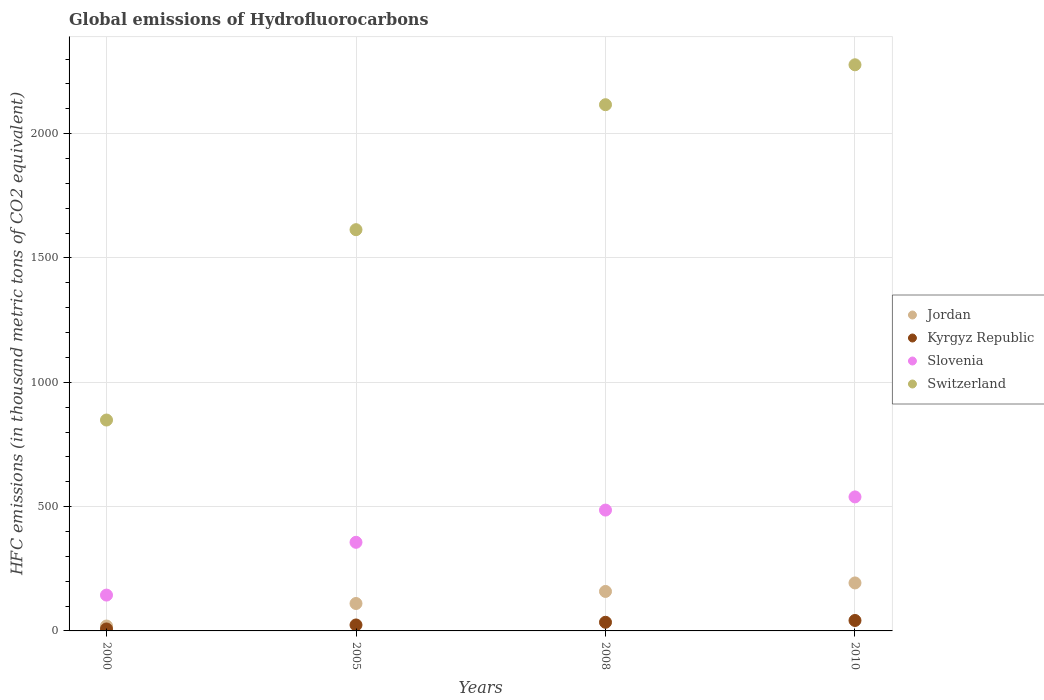How many different coloured dotlines are there?
Provide a short and direct response. 4. What is the global emissions of Hydrofluorocarbons in Switzerland in 2000?
Make the answer very short. 848.2. Across all years, what is the maximum global emissions of Hydrofluorocarbons in Switzerland?
Make the answer very short. 2277. In which year was the global emissions of Hydrofluorocarbons in Switzerland maximum?
Your response must be concise. 2010. What is the total global emissions of Hydrofluorocarbons in Switzerland in the graph?
Offer a very short reply. 6855.4. What is the difference between the global emissions of Hydrofluorocarbons in Switzerland in 2005 and that in 2010?
Give a very brief answer. -663.2. What is the difference between the global emissions of Hydrofluorocarbons in Switzerland in 2005 and the global emissions of Hydrofluorocarbons in Slovenia in 2010?
Provide a succinct answer. 1074.8. What is the average global emissions of Hydrofluorocarbons in Slovenia per year?
Your response must be concise. 381.38. In the year 2000, what is the difference between the global emissions of Hydrofluorocarbons in Jordan and global emissions of Hydrofluorocarbons in Slovenia?
Your answer should be compact. -124.4. What is the ratio of the global emissions of Hydrofluorocarbons in Jordan in 2000 to that in 2010?
Provide a succinct answer. 0.1. Is the global emissions of Hydrofluorocarbons in Kyrgyz Republic in 2005 less than that in 2010?
Keep it short and to the point. Yes. What is the difference between the highest and the second highest global emissions of Hydrofluorocarbons in Kyrgyz Republic?
Your answer should be compact. 7.2. What is the difference between the highest and the lowest global emissions of Hydrofluorocarbons in Jordan?
Provide a succinct answer. 173.3. In how many years, is the global emissions of Hydrofluorocarbons in Slovenia greater than the average global emissions of Hydrofluorocarbons in Slovenia taken over all years?
Your answer should be very brief. 2. Is it the case that in every year, the sum of the global emissions of Hydrofluorocarbons in Switzerland and global emissions of Hydrofluorocarbons in Slovenia  is greater than the sum of global emissions of Hydrofluorocarbons in Kyrgyz Republic and global emissions of Hydrofluorocarbons in Jordan?
Provide a succinct answer. Yes. Is the global emissions of Hydrofluorocarbons in Jordan strictly greater than the global emissions of Hydrofluorocarbons in Kyrgyz Republic over the years?
Your response must be concise. Yes. Is the global emissions of Hydrofluorocarbons in Switzerland strictly less than the global emissions of Hydrofluorocarbons in Jordan over the years?
Your answer should be very brief. No. How many dotlines are there?
Make the answer very short. 4. How many years are there in the graph?
Your response must be concise. 4. What is the difference between two consecutive major ticks on the Y-axis?
Offer a very short reply. 500. Does the graph contain any zero values?
Keep it short and to the point. No. Does the graph contain grids?
Offer a very short reply. Yes. How many legend labels are there?
Make the answer very short. 4. What is the title of the graph?
Make the answer very short. Global emissions of Hydrofluorocarbons. Does "Montenegro" appear as one of the legend labels in the graph?
Your answer should be very brief. No. What is the label or title of the Y-axis?
Offer a very short reply. HFC emissions (in thousand metric tons of CO2 equivalent). What is the HFC emissions (in thousand metric tons of CO2 equivalent) of Jordan in 2000?
Ensure brevity in your answer.  19.7. What is the HFC emissions (in thousand metric tons of CO2 equivalent) in Kyrgyz Republic in 2000?
Your response must be concise. 7.9. What is the HFC emissions (in thousand metric tons of CO2 equivalent) in Slovenia in 2000?
Give a very brief answer. 144.1. What is the HFC emissions (in thousand metric tons of CO2 equivalent) of Switzerland in 2000?
Give a very brief answer. 848.2. What is the HFC emissions (in thousand metric tons of CO2 equivalent) in Jordan in 2005?
Provide a short and direct response. 110.3. What is the HFC emissions (in thousand metric tons of CO2 equivalent) of Kyrgyz Republic in 2005?
Your response must be concise. 24. What is the HFC emissions (in thousand metric tons of CO2 equivalent) in Slovenia in 2005?
Provide a succinct answer. 356.4. What is the HFC emissions (in thousand metric tons of CO2 equivalent) in Switzerland in 2005?
Provide a short and direct response. 1613.8. What is the HFC emissions (in thousand metric tons of CO2 equivalent) in Jordan in 2008?
Provide a short and direct response. 158.8. What is the HFC emissions (in thousand metric tons of CO2 equivalent) in Kyrgyz Republic in 2008?
Offer a terse response. 34.8. What is the HFC emissions (in thousand metric tons of CO2 equivalent) of Slovenia in 2008?
Your response must be concise. 486. What is the HFC emissions (in thousand metric tons of CO2 equivalent) in Switzerland in 2008?
Your answer should be very brief. 2116.4. What is the HFC emissions (in thousand metric tons of CO2 equivalent) of Jordan in 2010?
Give a very brief answer. 193. What is the HFC emissions (in thousand metric tons of CO2 equivalent) in Slovenia in 2010?
Your response must be concise. 539. What is the HFC emissions (in thousand metric tons of CO2 equivalent) of Switzerland in 2010?
Your response must be concise. 2277. Across all years, what is the maximum HFC emissions (in thousand metric tons of CO2 equivalent) in Jordan?
Ensure brevity in your answer.  193. Across all years, what is the maximum HFC emissions (in thousand metric tons of CO2 equivalent) in Kyrgyz Republic?
Make the answer very short. 42. Across all years, what is the maximum HFC emissions (in thousand metric tons of CO2 equivalent) in Slovenia?
Keep it short and to the point. 539. Across all years, what is the maximum HFC emissions (in thousand metric tons of CO2 equivalent) of Switzerland?
Your answer should be compact. 2277. Across all years, what is the minimum HFC emissions (in thousand metric tons of CO2 equivalent) of Slovenia?
Provide a short and direct response. 144.1. Across all years, what is the minimum HFC emissions (in thousand metric tons of CO2 equivalent) in Switzerland?
Your answer should be very brief. 848.2. What is the total HFC emissions (in thousand metric tons of CO2 equivalent) of Jordan in the graph?
Your answer should be very brief. 481.8. What is the total HFC emissions (in thousand metric tons of CO2 equivalent) in Kyrgyz Republic in the graph?
Your answer should be compact. 108.7. What is the total HFC emissions (in thousand metric tons of CO2 equivalent) in Slovenia in the graph?
Ensure brevity in your answer.  1525.5. What is the total HFC emissions (in thousand metric tons of CO2 equivalent) in Switzerland in the graph?
Give a very brief answer. 6855.4. What is the difference between the HFC emissions (in thousand metric tons of CO2 equivalent) in Jordan in 2000 and that in 2005?
Keep it short and to the point. -90.6. What is the difference between the HFC emissions (in thousand metric tons of CO2 equivalent) of Kyrgyz Republic in 2000 and that in 2005?
Make the answer very short. -16.1. What is the difference between the HFC emissions (in thousand metric tons of CO2 equivalent) in Slovenia in 2000 and that in 2005?
Give a very brief answer. -212.3. What is the difference between the HFC emissions (in thousand metric tons of CO2 equivalent) of Switzerland in 2000 and that in 2005?
Keep it short and to the point. -765.6. What is the difference between the HFC emissions (in thousand metric tons of CO2 equivalent) in Jordan in 2000 and that in 2008?
Make the answer very short. -139.1. What is the difference between the HFC emissions (in thousand metric tons of CO2 equivalent) of Kyrgyz Republic in 2000 and that in 2008?
Your answer should be very brief. -26.9. What is the difference between the HFC emissions (in thousand metric tons of CO2 equivalent) in Slovenia in 2000 and that in 2008?
Keep it short and to the point. -341.9. What is the difference between the HFC emissions (in thousand metric tons of CO2 equivalent) of Switzerland in 2000 and that in 2008?
Give a very brief answer. -1268.2. What is the difference between the HFC emissions (in thousand metric tons of CO2 equivalent) in Jordan in 2000 and that in 2010?
Keep it short and to the point. -173.3. What is the difference between the HFC emissions (in thousand metric tons of CO2 equivalent) of Kyrgyz Republic in 2000 and that in 2010?
Your answer should be very brief. -34.1. What is the difference between the HFC emissions (in thousand metric tons of CO2 equivalent) in Slovenia in 2000 and that in 2010?
Keep it short and to the point. -394.9. What is the difference between the HFC emissions (in thousand metric tons of CO2 equivalent) in Switzerland in 2000 and that in 2010?
Offer a very short reply. -1428.8. What is the difference between the HFC emissions (in thousand metric tons of CO2 equivalent) of Jordan in 2005 and that in 2008?
Your answer should be compact. -48.5. What is the difference between the HFC emissions (in thousand metric tons of CO2 equivalent) of Slovenia in 2005 and that in 2008?
Make the answer very short. -129.6. What is the difference between the HFC emissions (in thousand metric tons of CO2 equivalent) in Switzerland in 2005 and that in 2008?
Give a very brief answer. -502.6. What is the difference between the HFC emissions (in thousand metric tons of CO2 equivalent) of Jordan in 2005 and that in 2010?
Provide a short and direct response. -82.7. What is the difference between the HFC emissions (in thousand metric tons of CO2 equivalent) in Kyrgyz Republic in 2005 and that in 2010?
Provide a short and direct response. -18. What is the difference between the HFC emissions (in thousand metric tons of CO2 equivalent) in Slovenia in 2005 and that in 2010?
Make the answer very short. -182.6. What is the difference between the HFC emissions (in thousand metric tons of CO2 equivalent) in Switzerland in 2005 and that in 2010?
Provide a succinct answer. -663.2. What is the difference between the HFC emissions (in thousand metric tons of CO2 equivalent) of Jordan in 2008 and that in 2010?
Provide a succinct answer. -34.2. What is the difference between the HFC emissions (in thousand metric tons of CO2 equivalent) of Slovenia in 2008 and that in 2010?
Provide a succinct answer. -53. What is the difference between the HFC emissions (in thousand metric tons of CO2 equivalent) of Switzerland in 2008 and that in 2010?
Offer a terse response. -160.6. What is the difference between the HFC emissions (in thousand metric tons of CO2 equivalent) of Jordan in 2000 and the HFC emissions (in thousand metric tons of CO2 equivalent) of Kyrgyz Republic in 2005?
Keep it short and to the point. -4.3. What is the difference between the HFC emissions (in thousand metric tons of CO2 equivalent) in Jordan in 2000 and the HFC emissions (in thousand metric tons of CO2 equivalent) in Slovenia in 2005?
Provide a succinct answer. -336.7. What is the difference between the HFC emissions (in thousand metric tons of CO2 equivalent) of Jordan in 2000 and the HFC emissions (in thousand metric tons of CO2 equivalent) of Switzerland in 2005?
Make the answer very short. -1594.1. What is the difference between the HFC emissions (in thousand metric tons of CO2 equivalent) in Kyrgyz Republic in 2000 and the HFC emissions (in thousand metric tons of CO2 equivalent) in Slovenia in 2005?
Give a very brief answer. -348.5. What is the difference between the HFC emissions (in thousand metric tons of CO2 equivalent) of Kyrgyz Republic in 2000 and the HFC emissions (in thousand metric tons of CO2 equivalent) of Switzerland in 2005?
Your answer should be very brief. -1605.9. What is the difference between the HFC emissions (in thousand metric tons of CO2 equivalent) in Slovenia in 2000 and the HFC emissions (in thousand metric tons of CO2 equivalent) in Switzerland in 2005?
Provide a short and direct response. -1469.7. What is the difference between the HFC emissions (in thousand metric tons of CO2 equivalent) in Jordan in 2000 and the HFC emissions (in thousand metric tons of CO2 equivalent) in Kyrgyz Republic in 2008?
Your answer should be very brief. -15.1. What is the difference between the HFC emissions (in thousand metric tons of CO2 equivalent) in Jordan in 2000 and the HFC emissions (in thousand metric tons of CO2 equivalent) in Slovenia in 2008?
Ensure brevity in your answer.  -466.3. What is the difference between the HFC emissions (in thousand metric tons of CO2 equivalent) of Jordan in 2000 and the HFC emissions (in thousand metric tons of CO2 equivalent) of Switzerland in 2008?
Make the answer very short. -2096.7. What is the difference between the HFC emissions (in thousand metric tons of CO2 equivalent) in Kyrgyz Republic in 2000 and the HFC emissions (in thousand metric tons of CO2 equivalent) in Slovenia in 2008?
Make the answer very short. -478.1. What is the difference between the HFC emissions (in thousand metric tons of CO2 equivalent) of Kyrgyz Republic in 2000 and the HFC emissions (in thousand metric tons of CO2 equivalent) of Switzerland in 2008?
Keep it short and to the point. -2108.5. What is the difference between the HFC emissions (in thousand metric tons of CO2 equivalent) of Slovenia in 2000 and the HFC emissions (in thousand metric tons of CO2 equivalent) of Switzerland in 2008?
Provide a succinct answer. -1972.3. What is the difference between the HFC emissions (in thousand metric tons of CO2 equivalent) of Jordan in 2000 and the HFC emissions (in thousand metric tons of CO2 equivalent) of Kyrgyz Republic in 2010?
Your answer should be compact. -22.3. What is the difference between the HFC emissions (in thousand metric tons of CO2 equivalent) in Jordan in 2000 and the HFC emissions (in thousand metric tons of CO2 equivalent) in Slovenia in 2010?
Keep it short and to the point. -519.3. What is the difference between the HFC emissions (in thousand metric tons of CO2 equivalent) of Jordan in 2000 and the HFC emissions (in thousand metric tons of CO2 equivalent) of Switzerland in 2010?
Keep it short and to the point. -2257.3. What is the difference between the HFC emissions (in thousand metric tons of CO2 equivalent) of Kyrgyz Republic in 2000 and the HFC emissions (in thousand metric tons of CO2 equivalent) of Slovenia in 2010?
Keep it short and to the point. -531.1. What is the difference between the HFC emissions (in thousand metric tons of CO2 equivalent) of Kyrgyz Republic in 2000 and the HFC emissions (in thousand metric tons of CO2 equivalent) of Switzerland in 2010?
Provide a short and direct response. -2269.1. What is the difference between the HFC emissions (in thousand metric tons of CO2 equivalent) of Slovenia in 2000 and the HFC emissions (in thousand metric tons of CO2 equivalent) of Switzerland in 2010?
Make the answer very short. -2132.9. What is the difference between the HFC emissions (in thousand metric tons of CO2 equivalent) of Jordan in 2005 and the HFC emissions (in thousand metric tons of CO2 equivalent) of Kyrgyz Republic in 2008?
Provide a succinct answer. 75.5. What is the difference between the HFC emissions (in thousand metric tons of CO2 equivalent) of Jordan in 2005 and the HFC emissions (in thousand metric tons of CO2 equivalent) of Slovenia in 2008?
Offer a very short reply. -375.7. What is the difference between the HFC emissions (in thousand metric tons of CO2 equivalent) in Jordan in 2005 and the HFC emissions (in thousand metric tons of CO2 equivalent) in Switzerland in 2008?
Your response must be concise. -2006.1. What is the difference between the HFC emissions (in thousand metric tons of CO2 equivalent) in Kyrgyz Republic in 2005 and the HFC emissions (in thousand metric tons of CO2 equivalent) in Slovenia in 2008?
Give a very brief answer. -462. What is the difference between the HFC emissions (in thousand metric tons of CO2 equivalent) of Kyrgyz Republic in 2005 and the HFC emissions (in thousand metric tons of CO2 equivalent) of Switzerland in 2008?
Make the answer very short. -2092.4. What is the difference between the HFC emissions (in thousand metric tons of CO2 equivalent) in Slovenia in 2005 and the HFC emissions (in thousand metric tons of CO2 equivalent) in Switzerland in 2008?
Offer a very short reply. -1760. What is the difference between the HFC emissions (in thousand metric tons of CO2 equivalent) of Jordan in 2005 and the HFC emissions (in thousand metric tons of CO2 equivalent) of Kyrgyz Republic in 2010?
Your answer should be very brief. 68.3. What is the difference between the HFC emissions (in thousand metric tons of CO2 equivalent) in Jordan in 2005 and the HFC emissions (in thousand metric tons of CO2 equivalent) in Slovenia in 2010?
Give a very brief answer. -428.7. What is the difference between the HFC emissions (in thousand metric tons of CO2 equivalent) of Jordan in 2005 and the HFC emissions (in thousand metric tons of CO2 equivalent) of Switzerland in 2010?
Provide a succinct answer. -2166.7. What is the difference between the HFC emissions (in thousand metric tons of CO2 equivalent) of Kyrgyz Republic in 2005 and the HFC emissions (in thousand metric tons of CO2 equivalent) of Slovenia in 2010?
Your response must be concise. -515. What is the difference between the HFC emissions (in thousand metric tons of CO2 equivalent) of Kyrgyz Republic in 2005 and the HFC emissions (in thousand metric tons of CO2 equivalent) of Switzerland in 2010?
Your response must be concise. -2253. What is the difference between the HFC emissions (in thousand metric tons of CO2 equivalent) in Slovenia in 2005 and the HFC emissions (in thousand metric tons of CO2 equivalent) in Switzerland in 2010?
Provide a short and direct response. -1920.6. What is the difference between the HFC emissions (in thousand metric tons of CO2 equivalent) in Jordan in 2008 and the HFC emissions (in thousand metric tons of CO2 equivalent) in Kyrgyz Republic in 2010?
Offer a very short reply. 116.8. What is the difference between the HFC emissions (in thousand metric tons of CO2 equivalent) in Jordan in 2008 and the HFC emissions (in thousand metric tons of CO2 equivalent) in Slovenia in 2010?
Make the answer very short. -380.2. What is the difference between the HFC emissions (in thousand metric tons of CO2 equivalent) of Jordan in 2008 and the HFC emissions (in thousand metric tons of CO2 equivalent) of Switzerland in 2010?
Your answer should be very brief. -2118.2. What is the difference between the HFC emissions (in thousand metric tons of CO2 equivalent) in Kyrgyz Republic in 2008 and the HFC emissions (in thousand metric tons of CO2 equivalent) in Slovenia in 2010?
Provide a short and direct response. -504.2. What is the difference between the HFC emissions (in thousand metric tons of CO2 equivalent) in Kyrgyz Republic in 2008 and the HFC emissions (in thousand metric tons of CO2 equivalent) in Switzerland in 2010?
Your answer should be very brief. -2242.2. What is the difference between the HFC emissions (in thousand metric tons of CO2 equivalent) in Slovenia in 2008 and the HFC emissions (in thousand metric tons of CO2 equivalent) in Switzerland in 2010?
Your answer should be compact. -1791. What is the average HFC emissions (in thousand metric tons of CO2 equivalent) of Jordan per year?
Give a very brief answer. 120.45. What is the average HFC emissions (in thousand metric tons of CO2 equivalent) in Kyrgyz Republic per year?
Give a very brief answer. 27.18. What is the average HFC emissions (in thousand metric tons of CO2 equivalent) in Slovenia per year?
Your response must be concise. 381.38. What is the average HFC emissions (in thousand metric tons of CO2 equivalent) in Switzerland per year?
Your answer should be compact. 1713.85. In the year 2000, what is the difference between the HFC emissions (in thousand metric tons of CO2 equivalent) in Jordan and HFC emissions (in thousand metric tons of CO2 equivalent) in Slovenia?
Offer a very short reply. -124.4. In the year 2000, what is the difference between the HFC emissions (in thousand metric tons of CO2 equivalent) of Jordan and HFC emissions (in thousand metric tons of CO2 equivalent) of Switzerland?
Offer a very short reply. -828.5. In the year 2000, what is the difference between the HFC emissions (in thousand metric tons of CO2 equivalent) in Kyrgyz Republic and HFC emissions (in thousand metric tons of CO2 equivalent) in Slovenia?
Provide a short and direct response. -136.2. In the year 2000, what is the difference between the HFC emissions (in thousand metric tons of CO2 equivalent) of Kyrgyz Republic and HFC emissions (in thousand metric tons of CO2 equivalent) of Switzerland?
Provide a short and direct response. -840.3. In the year 2000, what is the difference between the HFC emissions (in thousand metric tons of CO2 equivalent) in Slovenia and HFC emissions (in thousand metric tons of CO2 equivalent) in Switzerland?
Ensure brevity in your answer.  -704.1. In the year 2005, what is the difference between the HFC emissions (in thousand metric tons of CO2 equivalent) in Jordan and HFC emissions (in thousand metric tons of CO2 equivalent) in Kyrgyz Republic?
Provide a succinct answer. 86.3. In the year 2005, what is the difference between the HFC emissions (in thousand metric tons of CO2 equivalent) in Jordan and HFC emissions (in thousand metric tons of CO2 equivalent) in Slovenia?
Provide a succinct answer. -246.1. In the year 2005, what is the difference between the HFC emissions (in thousand metric tons of CO2 equivalent) of Jordan and HFC emissions (in thousand metric tons of CO2 equivalent) of Switzerland?
Ensure brevity in your answer.  -1503.5. In the year 2005, what is the difference between the HFC emissions (in thousand metric tons of CO2 equivalent) in Kyrgyz Republic and HFC emissions (in thousand metric tons of CO2 equivalent) in Slovenia?
Your answer should be compact. -332.4. In the year 2005, what is the difference between the HFC emissions (in thousand metric tons of CO2 equivalent) of Kyrgyz Republic and HFC emissions (in thousand metric tons of CO2 equivalent) of Switzerland?
Keep it short and to the point. -1589.8. In the year 2005, what is the difference between the HFC emissions (in thousand metric tons of CO2 equivalent) of Slovenia and HFC emissions (in thousand metric tons of CO2 equivalent) of Switzerland?
Your response must be concise. -1257.4. In the year 2008, what is the difference between the HFC emissions (in thousand metric tons of CO2 equivalent) of Jordan and HFC emissions (in thousand metric tons of CO2 equivalent) of Kyrgyz Republic?
Your response must be concise. 124. In the year 2008, what is the difference between the HFC emissions (in thousand metric tons of CO2 equivalent) in Jordan and HFC emissions (in thousand metric tons of CO2 equivalent) in Slovenia?
Keep it short and to the point. -327.2. In the year 2008, what is the difference between the HFC emissions (in thousand metric tons of CO2 equivalent) in Jordan and HFC emissions (in thousand metric tons of CO2 equivalent) in Switzerland?
Your response must be concise. -1957.6. In the year 2008, what is the difference between the HFC emissions (in thousand metric tons of CO2 equivalent) of Kyrgyz Republic and HFC emissions (in thousand metric tons of CO2 equivalent) of Slovenia?
Give a very brief answer. -451.2. In the year 2008, what is the difference between the HFC emissions (in thousand metric tons of CO2 equivalent) in Kyrgyz Republic and HFC emissions (in thousand metric tons of CO2 equivalent) in Switzerland?
Give a very brief answer. -2081.6. In the year 2008, what is the difference between the HFC emissions (in thousand metric tons of CO2 equivalent) in Slovenia and HFC emissions (in thousand metric tons of CO2 equivalent) in Switzerland?
Offer a very short reply. -1630.4. In the year 2010, what is the difference between the HFC emissions (in thousand metric tons of CO2 equivalent) of Jordan and HFC emissions (in thousand metric tons of CO2 equivalent) of Kyrgyz Republic?
Your answer should be very brief. 151. In the year 2010, what is the difference between the HFC emissions (in thousand metric tons of CO2 equivalent) in Jordan and HFC emissions (in thousand metric tons of CO2 equivalent) in Slovenia?
Your answer should be compact. -346. In the year 2010, what is the difference between the HFC emissions (in thousand metric tons of CO2 equivalent) of Jordan and HFC emissions (in thousand metric tons of CO2 equivalent) of Switzerland?
Offer a very short reply. -2084. In the year 2010, what is the difference between the HFC emissions (in thousand metric tons of CO2 equivalent) of Kyrgyz Republic and HFC emissions (in thousand metric tons of CO2 equivalent) of Slovenia?
Offer a terse response. -497. In the year 2010, what is the difference between the HFC emissions (in thousand metric tons of CO2 equivalent) in Kyrgyz Republic and HFC emissions (in thousand metric tons of CO2 equivalent) in Switzerland?
Provide a short and direct response. -2235. In the year 2010, what is the difference between the HFC emissions (in thousand metric tons of CO2 equivalent) of Slovenia and HFC emissions (in thousand metric tons of CO2 equivalent) of Switzerland?
Keep it short and to the point. -1738. What is the ratio of the HFC emissions (in thousand metric tons of CO2 equivalent) in Jordan in 2000 to that in 2005?
Your answer should be compact. 0.18. What is the ratio of the HFC emissions (in thousand metric tons of CO2 equivalent) in Kyrgyz Republic in 2000 to that in 2005?
Provide a short and direct response. 0.33. What is the ratio of the HFC emissions (in thousand metric tons of CO2 equivalent) in Slovenia in 2000 to that in 2005?
Ensure brevity in your answer.  0.4. What is the ratio of the HFC emissions (in thousand metric tons of CO2 equivalent) in Switzerland in 2000 to that in 2005?
Your response must be concise. 0.53. What is the ratio of the HFC emissions (in thousand metric tons of CO2 equivalent) of Jordan in 2000 to that in 2008?
Your answer should be compact. 0.12. What is the ratio of the HFC emissions (in thousand metric tons of CO2 equivalent) in Kyrgyz Republic in 2000 to that in 2008?
Ensure brevity in your answer.  0.23. What is the ratio of the HFC emissions (in thousand metric tons of CO2 equivalent) of Slovenia in 2000 to that in 2008?
Make the answer very short. 0.3. What is the ratio of the HFC emissions (in thousand metric tons of CO2 equivalent) of Switzerland in 2000 to that in 2008?
Give a very brief answer. 0.4. What is the ratio of the HFC emissions (in thousand metric tons of CO2 equivalent) in Jordan in 2000 to that in 2010?
Give a very brief answer. 0.1. What is the ratio of the HFC emissions (in thousand metric tons of CO2 equivalent) of Kyrgyz Republic in 2000 to that in 2010?
Your answer should be compact. 0.19. What is the ratio of the HFC emissions (in thousand metric tons of CO2 equivalent) in Slovenia in 2000 to that in 2010?
Keep it short and to the point. 0.27. What is the ratio of the HFC emissions (in thousand metric tons of CO2 equivalent) of Switzerland in 2000 to that in 2010?
Offer a very short reply. 0.37. What is the ratio of the HFC emissions (in thousand metric tons of CO2 equivalent) in Jordan in 2005 to that in 2008?
Give a very brief answer. 0.69. What is the ratio of the HFC emissions (in thousand metric tons of CO2 equivalent) in Kyrgyz Republic in 2005 to that in 2008?
Your answer should be compact. 0.69. What is the ratio of the HFC emissions (in thousand metric tons of CO2 equivalent) in Slovenia in 2005 to that in 2008?
Provide a short and direct response. 0.73. What is the ratio of the HFC emissions (in thousand metric tons of CO2 equivalent) of Switzerland in 2005 to that in 2008?
Ensure brevity in your answer.  0.76. What is the ratio of the HFC emissions (in thousand metric tons of CO2 equivalent) of Jordan in 2005 to that in 2010?
Keep it short and to the point. 0.57. What is the ratio of the HFC emissions (in thousand metric tons of CO2 equivalent) of Slovenia in 2005 to that in 2010?
Your response must be concise. 0.66. What is the ratio of the HFC emissions (in thousand metric tons of CO2 equivalent) in Switzerland in 2005 to that in 2010?
Your response must be concise. 0.71. What is the ratio of the HFC emissions (in thousand metric tons of CO2 equivalent) in Jordan in 2008 to that in 2010?
Offer a terse response. 0.82. What is the ratio of the HFC emissions (in thousand metric tons of CO2 equivalent) in Kyrgyz Republic in 2008 to that in 2010?
Offer a terse response. 0.83. What is the ratio of the HFC emissions (in thousand metric tons of CO2 equivalent) in Slovenia in 2008 to that in 2010?
Keep it short and to the point. 0.9. What is the ratio of the HFC emissions (in thousand metric tons of CO2 equivalent) of Switzerland in 2008 to that in 2010?
Ensure brevity in your answer.  0.93. What is the difference between the highest and the second highest HFC emissions (in thousand metric tons of CO2 equivalent) in Jordan?
Offer a very short reply. 34.2. What is the difference between the highest and the second highest HFC emissions (in thousand metric tons of CO2 equivalent) of Switzerland?
Keep it short and to the point. 160.6. What is the difference between the highest and the lowest HFC emissions (in thousand metric tons of CO2 equivalent) in Jordan?
Provide a succinct answer. 173.3. What is the difference between the highest and the lowest HFC emissions (in thousand metric tons of CO2 equivalent) in Kyrgyz Republic?
Make the answer very short. 34.1. What is the difference between the highest and the lowest HFC emissions (in thousand metric tons of CO2 equivalent) of Slovenia?
Offer a terse response. 394.9. What is the difference between the highest and the lowest HFC emissions (in thousand metric tons of CO2 equivalent) in Switzerland?
Your answer should be compact. 1428.8. 